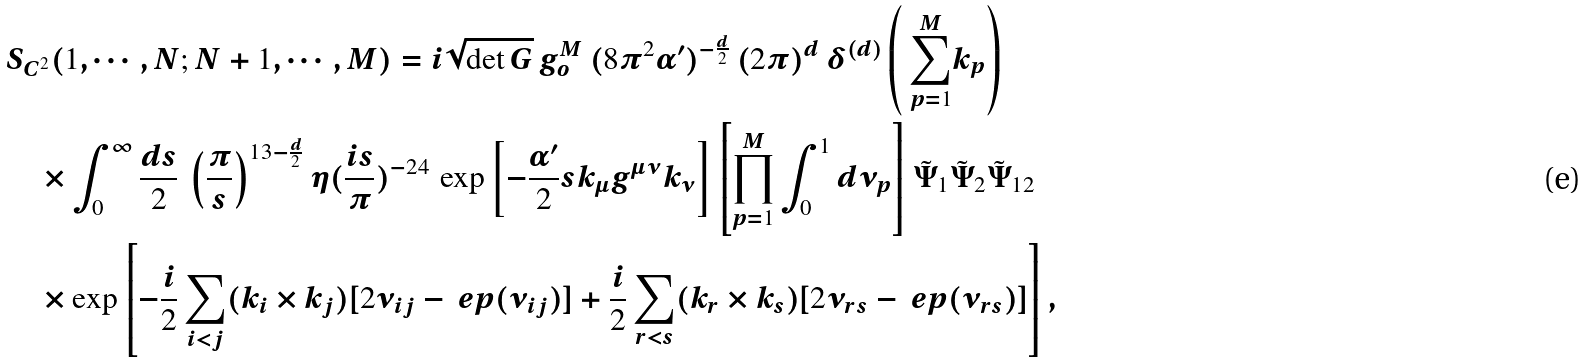Convert formula to latex. <formula><loc_0><loc_0><loc_500><loc_500>& S _ { C ^ { 2 } } ( 1 , \cdots , N ; N + 1 , \cdots , M ) = i \sqrt { \det G } \, g _ { o } ^ { M } \, ( 8 \pi ^ { 2 } \alpha ^ { \prime } ) ^ { - \frac { d } { 2 } } \, ( 2 \pi ) ^ { d } \, \delta ^ { ( d ) } \left ( \text { $\sum_{p=1}^{M}$} k _ { p } \right ) \\ & \quad \times \int _ { 0 } ^ { \infty } \frac { d s } { 2 } \, \left ( \frac { \pi } { s } \right ) ^ { 1 3 - \frac { d } { 2 } } \eta ( \frac { i s } { \pi } ) ^ { - 2 4 } \, \exp \left [ - \frac { \alpha ^ { \prime } } { 2 } s k _ { \mu } g ^ { \mu \nu } k _ { \nu } \right ] \left [ \prod _ { p = 1 } ^ { M } \int _ { 0 } ^ { 1 } d \nu _ { p } \right ] \tilde { \Psi } _ { 1 } \tilde { \Psi } _ { 2 } \tilde { \Psi } _ { 1 2 } \\ & \quad \times \exp \left [ - \frac { i } { 2 } \sum _ { i < j } ( k _ { i } \times k _ { j } ) [ 2 \nu _ { i j } - \ e p ( \nu _ { i j } ) ] + \frac { i } { 2 } \sum _ { r < s } ( k _ { r } \times k _ { s } ) [ 2 \nu _ { r s } - \ e p ( \nu _ { r s } ) ] \right ] ,</formula> 